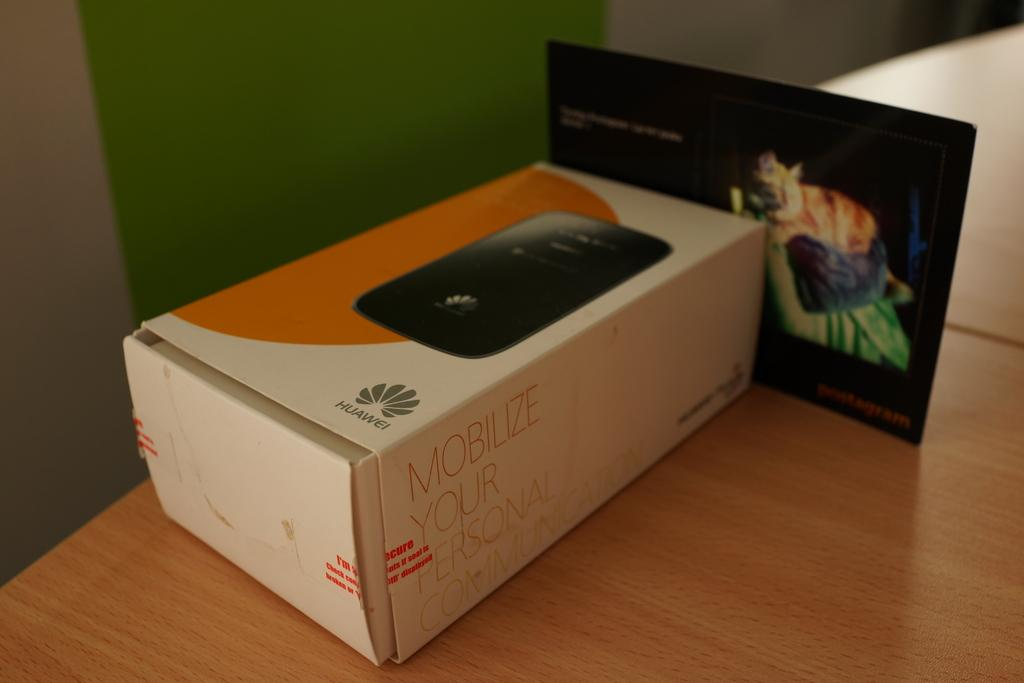Provide a one-sentence caption for the provided image. A Huawei product box with he words Mobilize your personal communication on the side. 